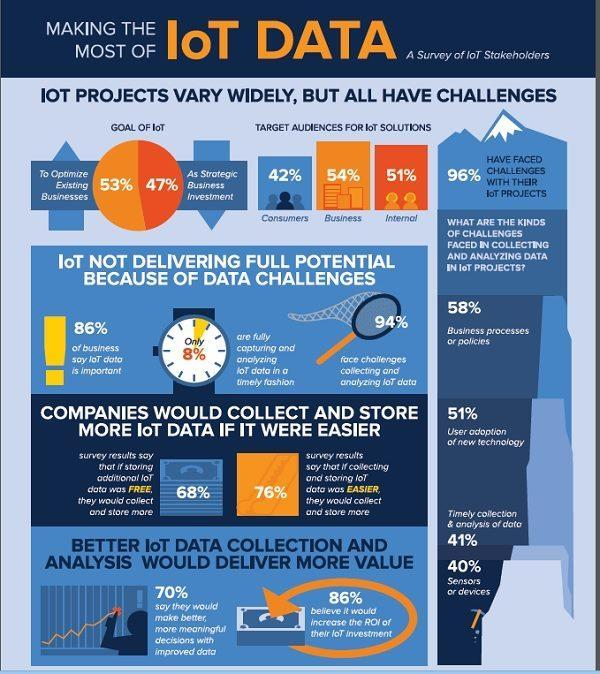What percentage do not believe that better IoT data collection would increase the ROI?
Answer the question with a short phrase. 14% Which is the major challenge faced in collection and analysis of data? Business processes or policies Which target audience for IoT solutions has maximum numbers? Business What percentage fully capture and analyze IoT data timely? 8% What percentage of IoT is for business investment? 47% How many kinds of challenges are faced in collecting and analysing data in IoT projects? 4 What percentage have not faced challenges with their IoT projects? 4% 